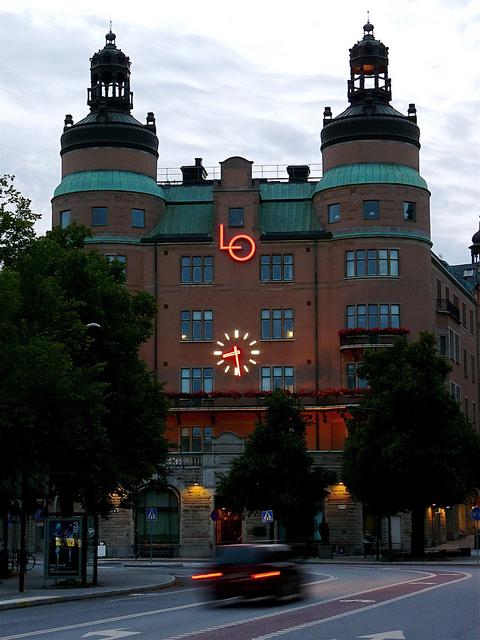What time is it?
Keep it brief. 8:29. Is the picture blurry?
Keep it brief. Yes. What does the neon sign say on the building?
Be succinct. Lo. 